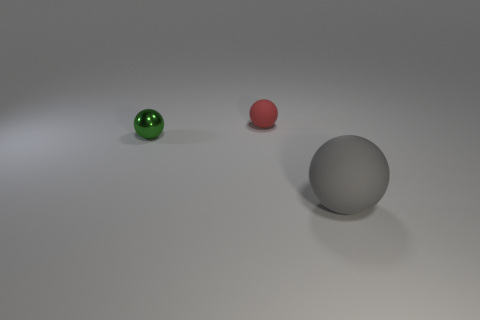There is a matte thing that is behind the green thing; is it the same size as the large object?
Ensure brevity in your answer.  No. There is another object that is the same size as the red matte thing; what is its shape?
Your response must be concise. Sphere. Is the large object the same shape as the tiny green metallic thing?
Make the answer very short. Yes. How many other small objects have the same shape as the small green object?
Ensure brevity in your answer.  1. What number of tiny objects are behind the tiny green object?
Keep it short and to the point. 1. There is a ball behind the green metal sphere; is its color the same as the large rubber object?
Offer a very short reply. No. How many metallic objects are the same size as the red ball?
Make the answer very short. 1. What shape is the thing that is made of the same material as the gray ball?
Your answer should be very brief. Sphere. Is there another ball that has the same color as the metallic ball?
Your answer should be very brief. No. What material is the gray object?
Provide a succinct answer. Rubber. 